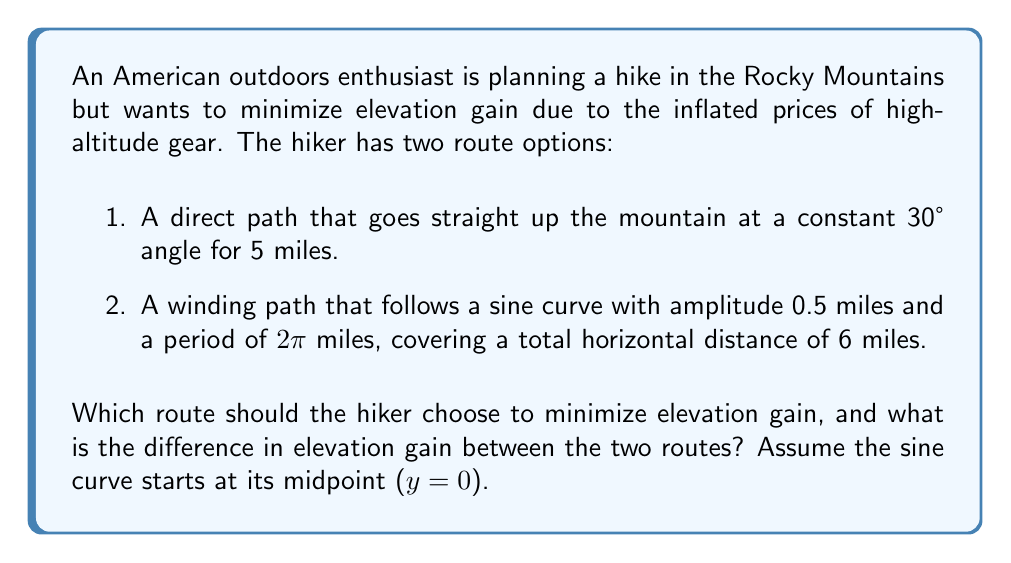Solve this math problem. Let's analyze each route separately:

1. Direct path:
The elevation gain for the direct path can be calculated using the sine function:
$$\text{Elevation gain}_{\text{direct}} = 5 \cdot \sin(30°) = 5 \cdot 0.5 = 2.5 \text{ miles}$$

2. Winding path:
For the winding path, we need to calculate the arc length of the sine curve. The formula for arc length of a function $f(x)$ over an interval $[a,b]$ is:

$$L = \int_a^b \sqrt{1 + [f'(x)]^2} dx$$

In our case, $f(x) = 0.5 \sin(\frac{\pi}{3}x)$ (to make the period 6 miles), and $f'(x) = 0.5 \cdot \frac{\pi}{3} \cos(\frac{\pi}{3}x)$

Substituting into the arc length formula:

$$L = \int_0^6 \sqrt{1 + [0.5 \cdot \frac{\pi}{3} \cos(\frac{\pi}{3}x)]^2} dx$$

This integral is complex and doesn't have a simple closed-form solution. We can approximate it numerically:

$$L \approx 6.0857 \text{ miles}$$

The elevation gain is the difference between the highest and lowest points of the sine curve:

$$\text{Elevation gain}_{\text{winding}} = 2 \cdot 0.5 = 1 \text{ mile}$$

Comparing the two routes:
$$\text{Difference} = 2.5 - 1 = 1.5 \text{ miles}$$
Answer: The hiker should choose the winding path to minimize elevation gain. The difference in elevation gain between the two routes is 1.5 miles, with the winding path having 1.5 miles less elevation gain than the direct path. 